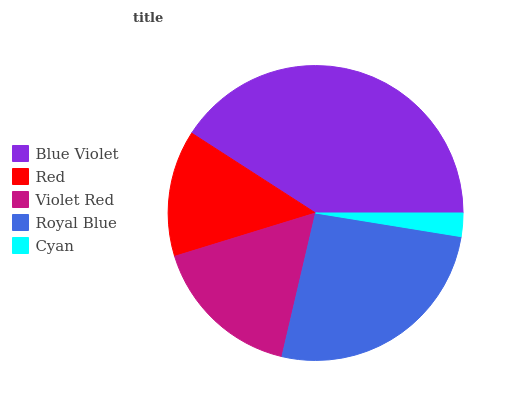Is Cyan the minimum?
Answer yes or no. Yes. Is Blue Violet the maximum?
Answer yes or no. Yes. Is Red the minimum?
Answer yes or no. No. Is Red the maximum?
Answer yes or no. No. Is Blue Violet greater than Red?
Answer yes or no. Yes. Is Red less than Blue Violet?
Answer yes or no. Yes. Is Red greater than Blue Violet?
Answer yes or no. No. Is Blue Violet less than Red?
Answer yes or no. No. Is Violet Red the high median?
Answer yes or no. Yes. Is Violet Red the low median?
Answer yes or no. Yes. Is Blue Violet the high median?
Answer yes or no. No. Is Cyan the low median?
Answer yes or no. No. 